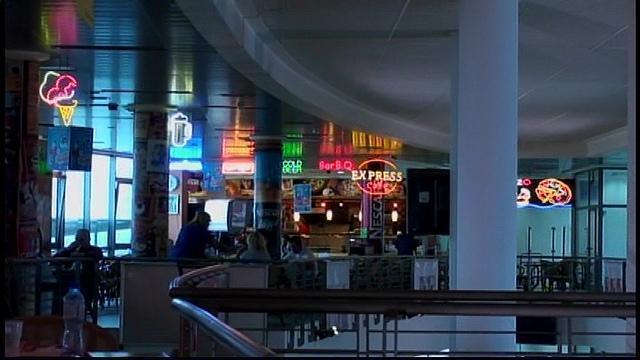How many chairs are in the picture?
Give a very brief answer. 2. 